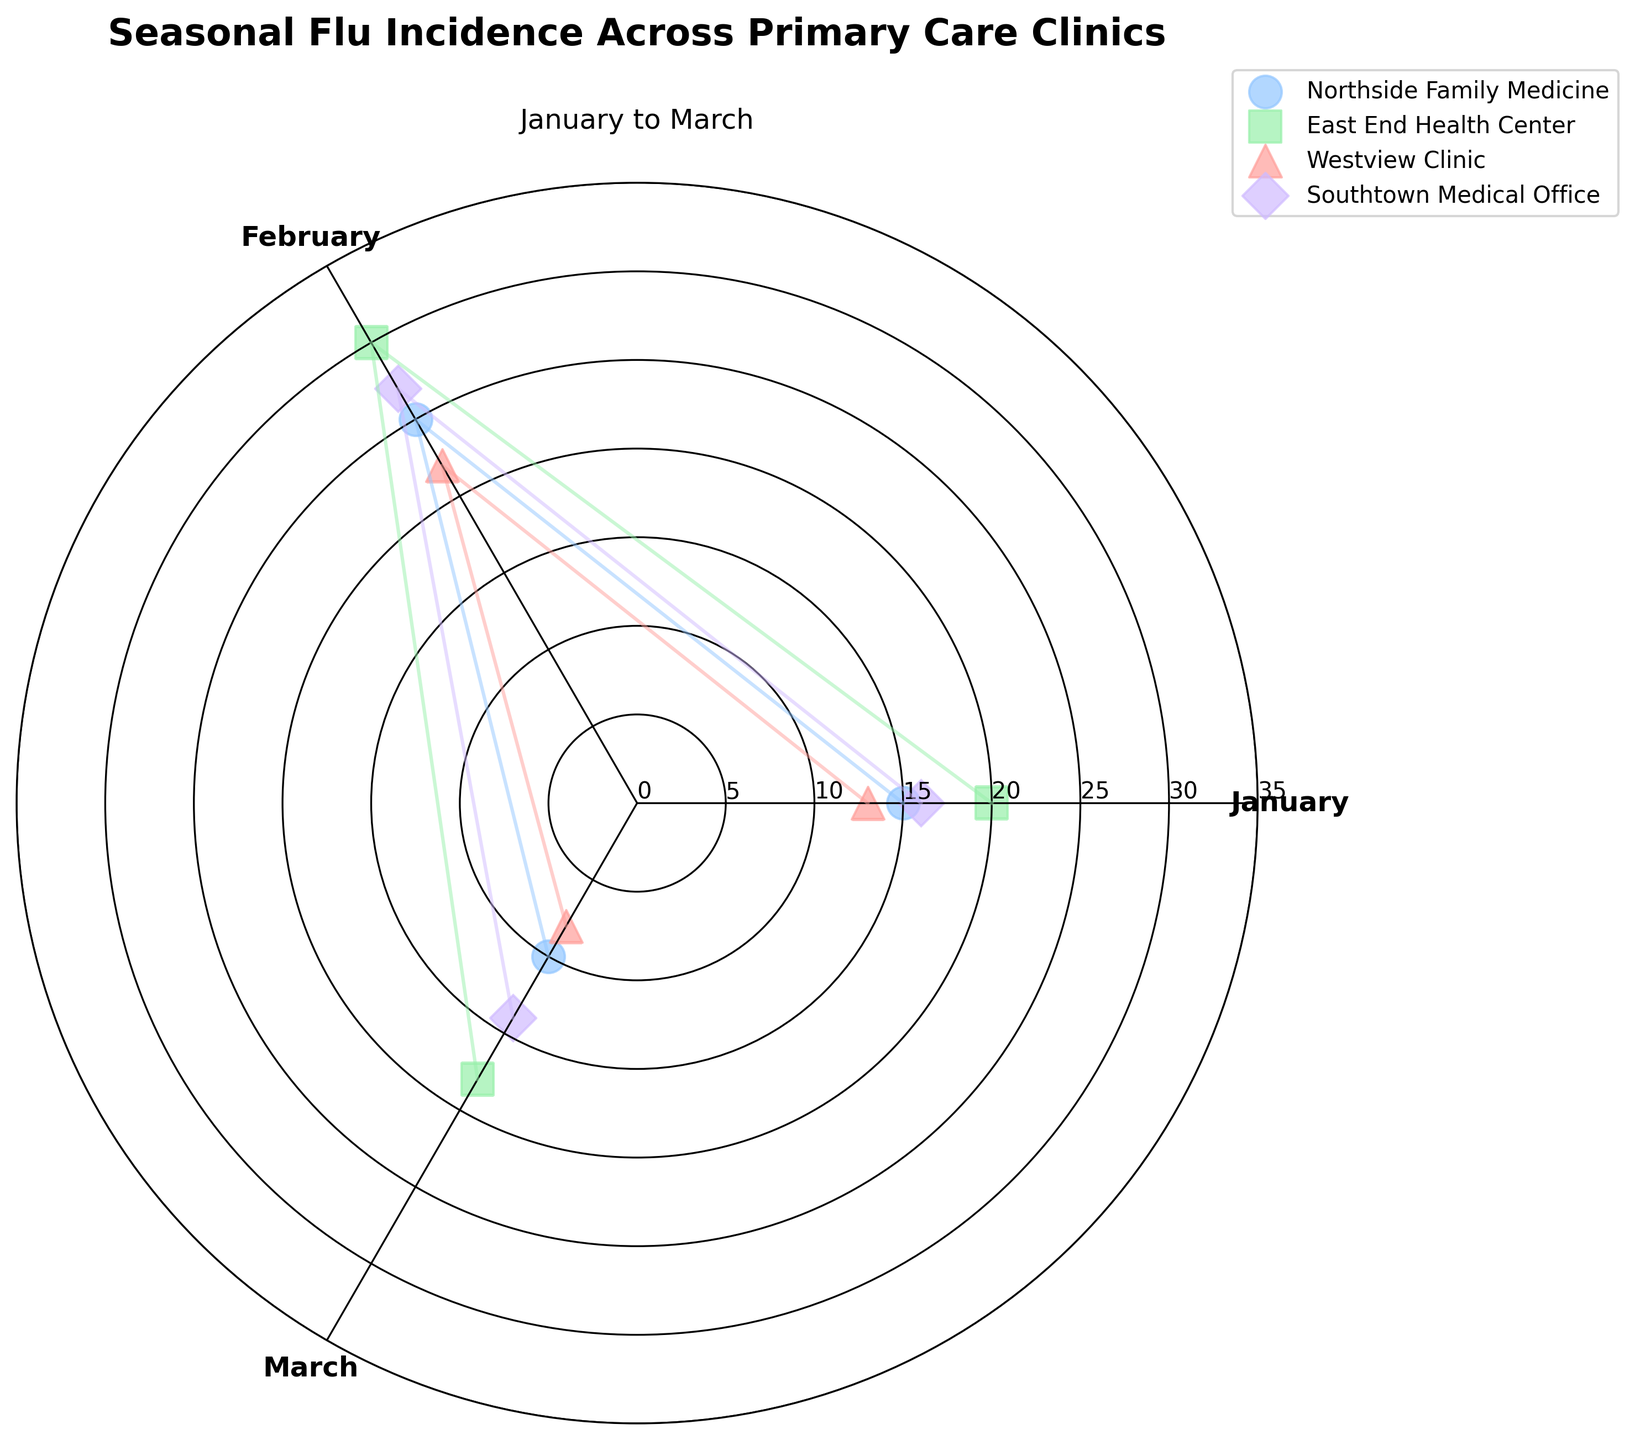Which clinic had the highest flu incidence in February? In February, Northside Family Medicine reported 25 cases, East End Health Center reported 30 cases, Westview Clinic reported 22 cases, and Southtown Medical Office reported 27 cases. Among these, East End Health Center had the highest incidence.
Answer: East End Health Center What is the title of the chart? The chart title is clearly written at the top of the plot which reads: "Seasonal Flu Incidence Across Primary Care Clinics".
Answer: Seasonal Flu Incidence Across Primary Care Clinics Which month had the lowest overall flu incidence? By comparing the incidence rates across all clinics for each month:
- January: 15 + 20 + 13 + 16 = 64
- February: 25 + 30 + 22 + 27 = 104
- March: 10 + 18 + 8 + 14 = 50
March had the lowest overall incidence with a total of 50 cases.
Answer: March What marker shapes represent Northside Family Medicine and East End Health Center? Northside Family Medicine uses circles (o), and East End Health Center uses squares (s), as indicated by the different marker styles in the scatter plot.
Answer: Circles and squares Which month did Westview Clinic have the lowest incidence of flu? For Westview Clinic, the incidence rates for each month are:
- January: 13
- February: 22
- March: 8
The lowest incidence is in March with 8 cases.
Answer: March What is the incidence difference between January and March for Southtown Medical Office? The incidence for Southtown Medical Office in January is 16, and in March it is 14. The difference is 16 - 14 = 2.
Answer: 2 Which clinic had the most fluctuating flu incidence among the three months? To find the most fluctuating clinic, we compare the ranges (max - min) of incidences for each clinic over the three months:
- Northside Family Medicine: 25 - 10 = 15
- East End Health Center: 30 - 18 = 12
- Westview Clinic: 22 - 8 = 14
- Southtown Medical Office: 27 - 14 = 13
Northside Family Medicine has the highest range of 15, indicating the most fluctuation.
Answer: Northside Family Medicine How many primary care clinics are represented in the chart? The plot includes Northside Family Medicine, East End Health Center, Westview Clinic, and Southtown Medical Office. By counting these clinics, we see there are four clinics represented.
Answer: 4 